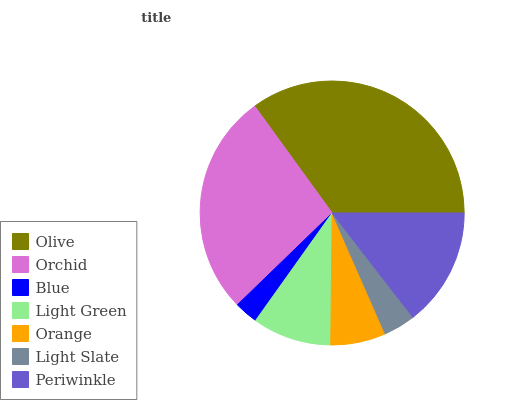Is Blue the minimum?
Answer yes or no. Yes. Is Olive the maximum?
Answer yes or no. Yes. Is Orchid the minimum?
Answer yes or no. No. Is Orchid the maximum?
Answer yes or no. No. Is Olive greater than Orchid?
Answer yes or no. Yes. Is Orchid less than Olive?
Answer yes or no. Yes. Is Orchid greater than Olive?
Answer yes or no. No. Is Olive less than Orchid?
Answer yes or no. No. Is Light Green the high median?
Answer yes or no. Yes. Is Light Green the low median?
Answer yes or no. Yes. Is Periwinkle the high median?
Answer yes or no. No. Is Periwinkle the low median?
Answer yes or no. No. 